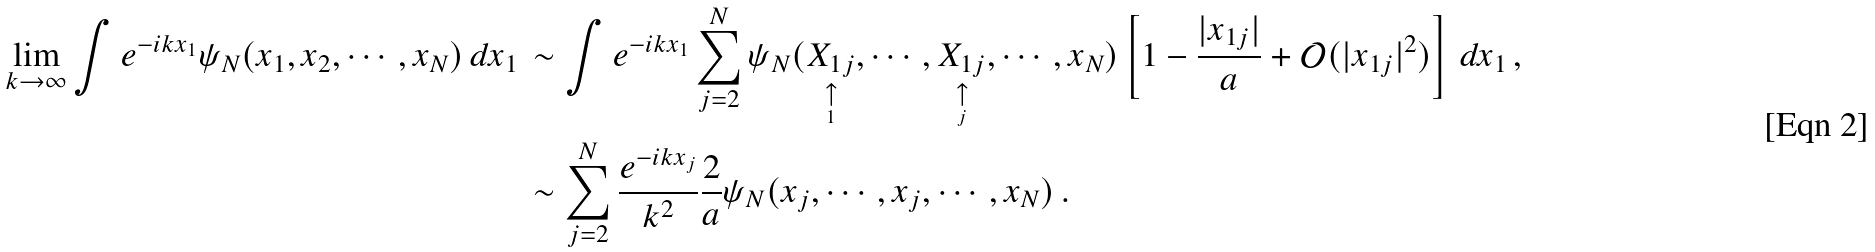Convert formula to latex. <formula><loc_0><loc_0><loc_500><loc_500>\lim _ { k \rightarrow \infty } \int e ^ { - i k x _ { 1 } } \psi _ { N } ( x _ { 1 } , x _ { 2 } , \cdots , x _ { N } ) \, d x _ { 1 } \, & \sim \int e ^ { - i k x _ { 1 } } \sum _ { j = 2 } ^ { N } \psi _ { N } ( \underset { \underset { 1 } { \uparrow } } { X _ { 1 j } } , \cdots , \underset { \underset { j } { \uparrow } } { X _ { 1 j } } , \cdots , x _ { N } ) \left [ 1 - \frac { | x _ { 1 j } | } { a } + \mathcal { O } ( | x _ { 1 j } | ^ { 2 } ) \right ] \, d x _ { 1 } \, , \\ & \sim \sum _ { j = 2 } ^ { N } \frac { e ^ { - i k x _ { j } } } { k ^ { 2 } } \frac { 2 } { a } \psi _ { N } ( x _ { j } , \cdots , x _ { j } , \cdots , x _ { N } ) \, .</formula> 